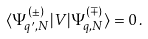Convert formula to latex. <formula><loc_0><loc_0><loc_500><loc_500>\langle \Psi _ { q ^ { \prime } , N } ^ { ( \pm ) } | { V } | \Psi _ { q , N } ^ { ( \mp ) } \rangle = 0 \, .</formula> 